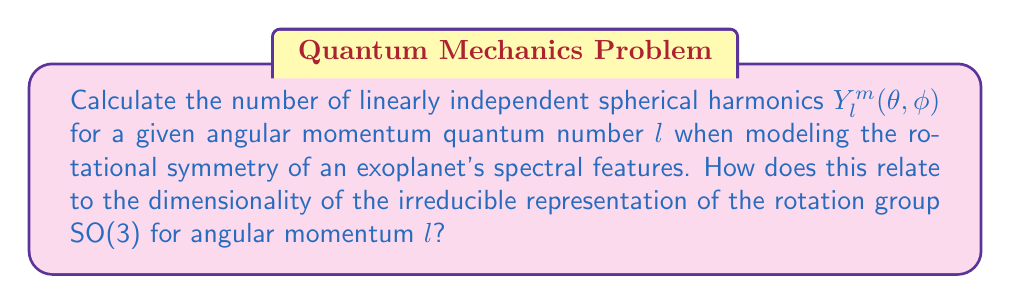Give your solution to this math problem. To solve this problem, we'll follow these steps:

1) Recall that for a given $l$, the magnetic quantum number $m$ can take values from $-l$ to $+l$ in integer steps.

2) Count the number of possible $m$ values:
   $$\text{Number of } m \text{ values} = (l - (-l)) + 1 = 2l + 1$$

3) Each unique combination of $l$ and $m$ corresponds to a linearly independent spherical harmonic $Y_l^m(\theta, \phi)$.

4) Therefore, for a given $l$, there are $2l + 1$ linearly independent spherical harmonics.

5) In representation theory, the dimensionality of an irreducible representation of SO(3) for angular momentum $l$ is also $2l + 1$.

6) This correspondence is not coincidental. The spherical harmonics $Y_l^m(\theta, \phi)$ form a basis for the $(2l+1)$-dimensional irreducible representation of SO(3).

7) This relationship is crucial in spectroscopy of exoplanets because:
   a) It allows us to decompose complex spectral patterns into simpler, rotationally invariant components.
   b) It provides a natural way to describe the angular distribution of spectral features on a spherical planet.
   c) It facilitates the analysis of how spectral features transform under rotations, which is essential for understanding the planet's rotational state and atmospheric dynamics.
Answer: $2l + 1$ 